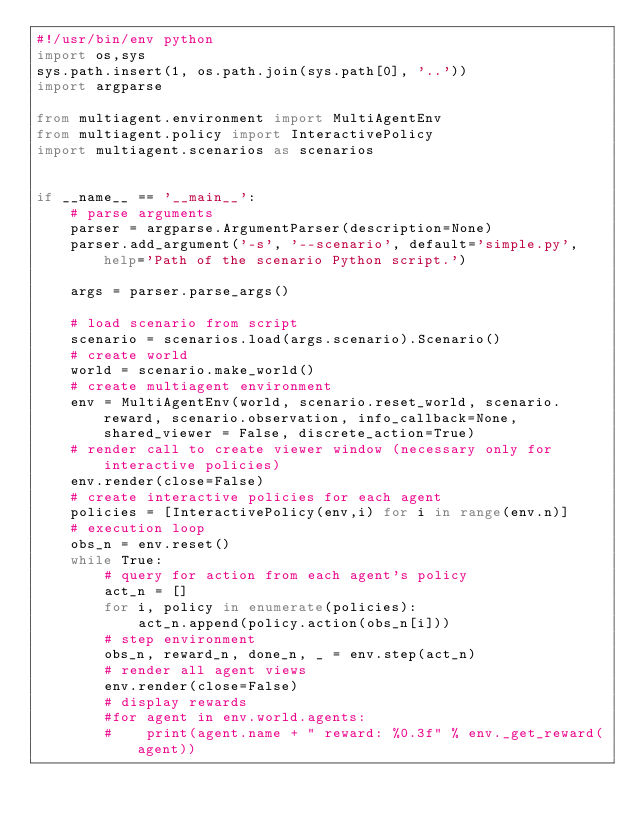Convert code to text. <code><loc_0><loc_0><loc_500><loc_500><_Python_>#!/usr/bin/env python
import os,sys
sys.path.insert(1, os.path.join(sys.path[0], '..'))
import argparse

from multiagent.environment import MultiAgentEnv
from multiagent.policy import InteractivePolicy
import multiagent.scenarios as scenarios


if __name__ == '__main__':
    # parse arguments
    parser = argparse.ArgumentParser(description=None)
    parser.add_argument('-s', '--scenario', default='simple.py', help='Path of the scenario Python script.')

    args = parser.parse_args()

    # load scenario from script
    scenario = scenarios.load(args.scenario).Scenario()
    # create world
    world = scenario.make_world()
    # create multiagent environment
    env = MultiAgentEnv(world, scenario.reset_world, scenario.reward, scenario.observation, info_callback=None, shared_viewer = False, discrete_action=True)
    # render call to create viewer window (necessary only for interactive policies)
    env.render(close=False)
    # create interactive policies for each agent
    policies = [InteractivePolicy(env,i) for i in range(env.n)]
    # execution loop
    obs_n = env.reset()
    while True:
        # query for action from each agent's policy
        act_n = []
        for i, policy in enumerate(policies):
            act_n.append(policy.action(obs_n[i]))
        # step environment
        obs_n, reward_n, done_n, _ = env.step(act_n)
        # render all agent views
        env.render(close=False)
        # display rewards
        #for agent in env.world.agents:
        #    print(agent.name + " reward: %0.3f" % env._get_reward(agent))
</code> 